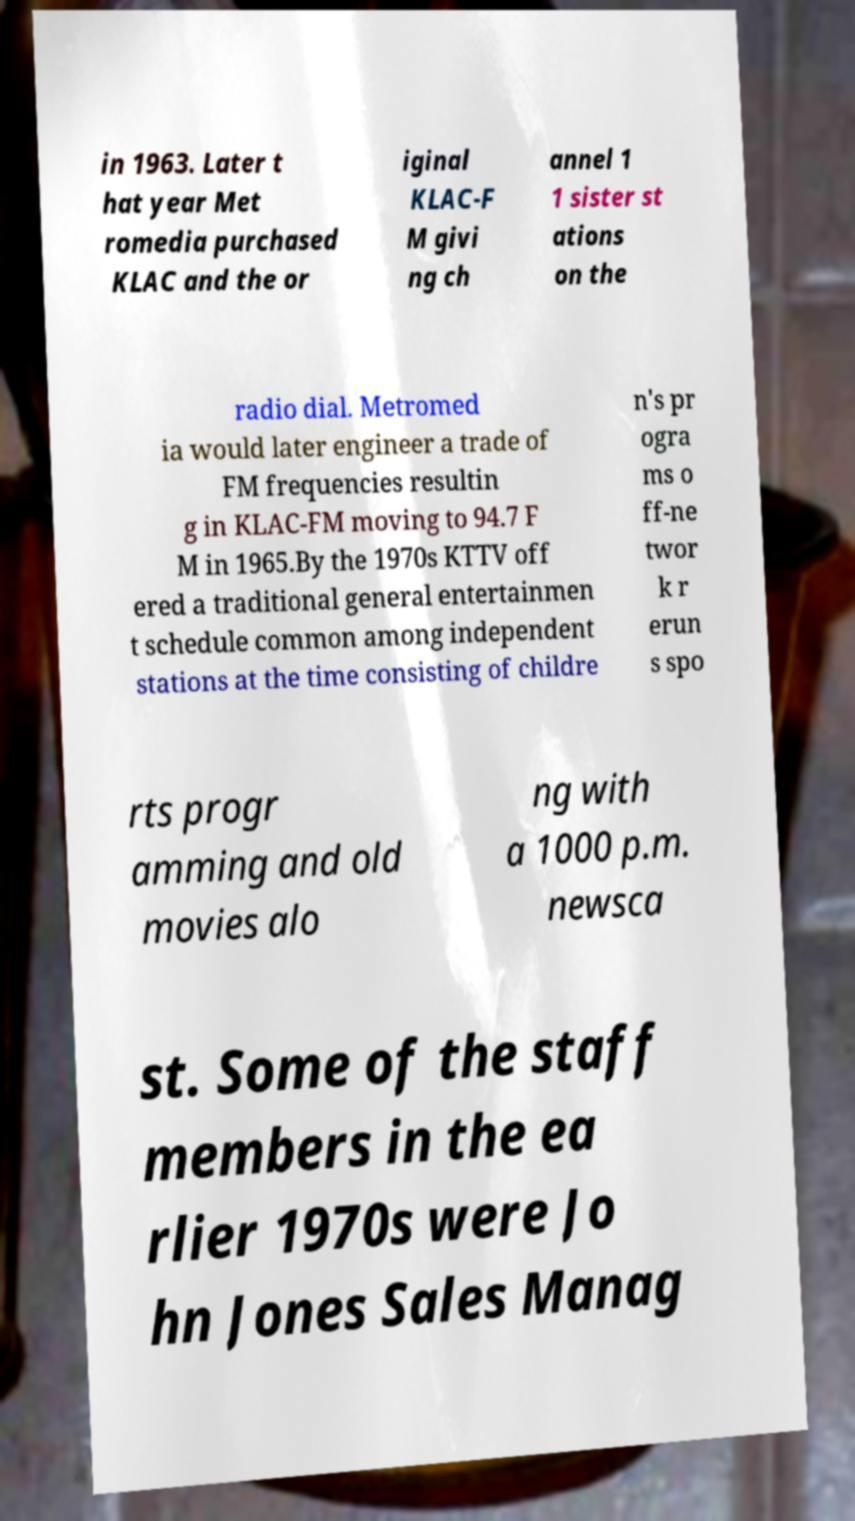Could you extract and type out the text from this image? in 1963. Later t hat year Met romedia purchased KLAC and the or iginal KLAC-F M givi ng ch annel 1 1 sister st ations on the radio dial. Metromed ia would later engineer a trade of FM frequencies resultin g in KLAC-FM moving to 94.7 F M in 1965.By the 1970s KTTV off ered a traditional general entertainmen t schedule common among independent stations at the time consisting of childre n's pr ogra ms o ff-ne twor k r erun s spo rts progr amming and old movies alo ng with a 1000 p.m. newsca st. Some of the staff members in the ea rlier 1970s were Jo hn Jones Sales Manag 